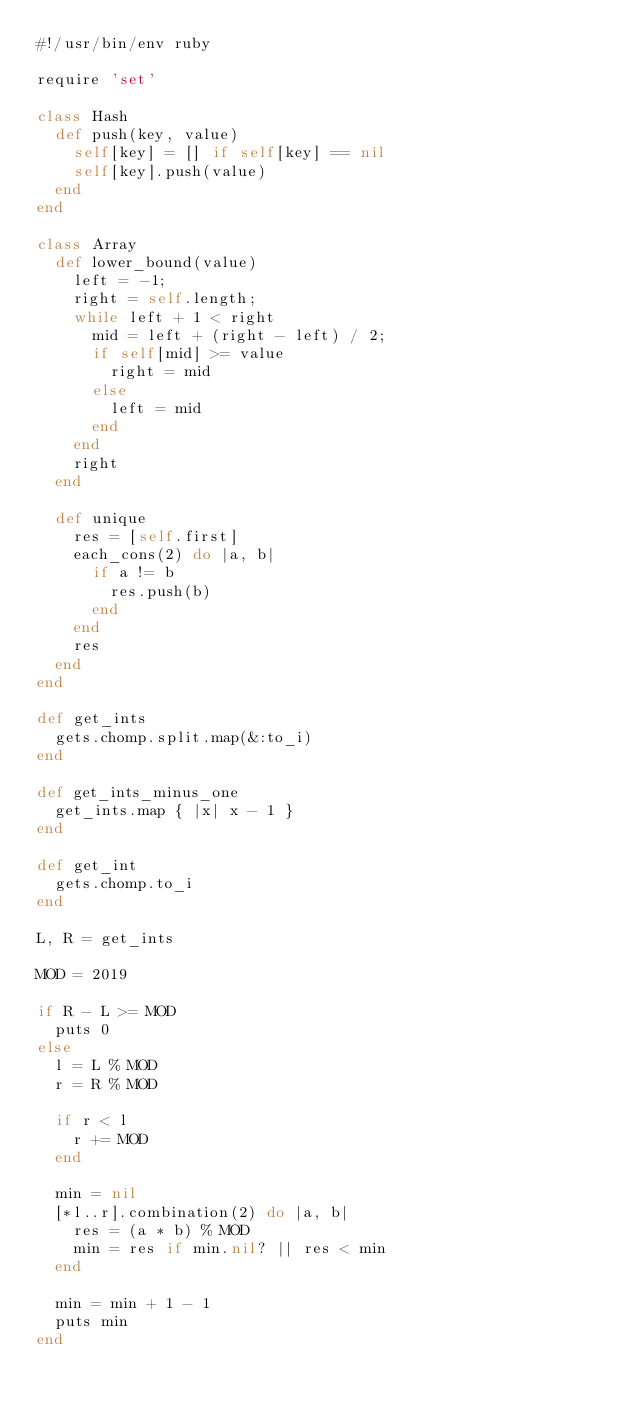<code> <loc_0><loc_0><loc_500><loc_500><_Ruby_>#!/usr/bin/env ruby

require 'set'

class Hash
  def push(key, value)
    self[key] = [] if self[key] == nil
    self[key].push(value)
  end
end

class Array
  def lower_bound(value)
    left = -1;
    right = self.length;
    while left + 1 < right
      mid = left + (right - left) / 2;
      if self[mid] >= value
        right = mid
      else
        left = mid
      end
    end
    right
  end

  def unique
    res = [self.first]
    each_cons(2) do |a, b|
      if a != b
        res.push(b)
      end
    end
    res
  end
end

def get_ints
  gets.chomp.split.map(&:to_i)
end

def get_ints_minus_one
  get_ints.map { |x| x - 1 }
end

def get_int
  gets.chomp.to_i
end

L, R = get_ints

MOD = 2019

if R - L >= MOD
  puts 0
else
  l = L % MOD
  r = R % MOD

  if r < l
    r += MOD
  end

  min = nil
  [*l..r].combination(2) do |a, b|
    res = (a * b) % MOD
    min = res if min.nil? || res < min
  end

  min = min + 1 - 1
  puts min
end
</code> 